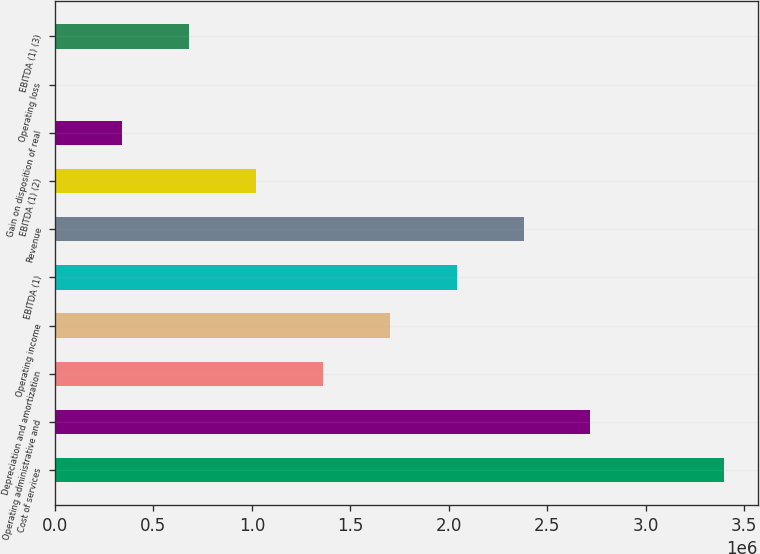<chart> <loc_0><loc_0><loc_500><loc_500><bar_chart><fcel>Cost of services<fcel>Operating administrative and<fcel>Depreciation and amortization<fcel>Operating income<fcel>EBITDA (1)<fcel>Revenue<fcel>EBITDA (1) (2)<fcel>Gain on disposition of real<fcel>Operating loss<fcel>EBITDA (1) (3)<nl><fcel>3.39844e+06<fcel>2.7193e+06<fcel>1.36103e+06<fcel>1.7006e+06<fcel>2.04016e+06<fcel>2.37973e+06<fcel>1.02146e+06<fcel>342317<fcel>2747<fcel>681886<nl></chart> 